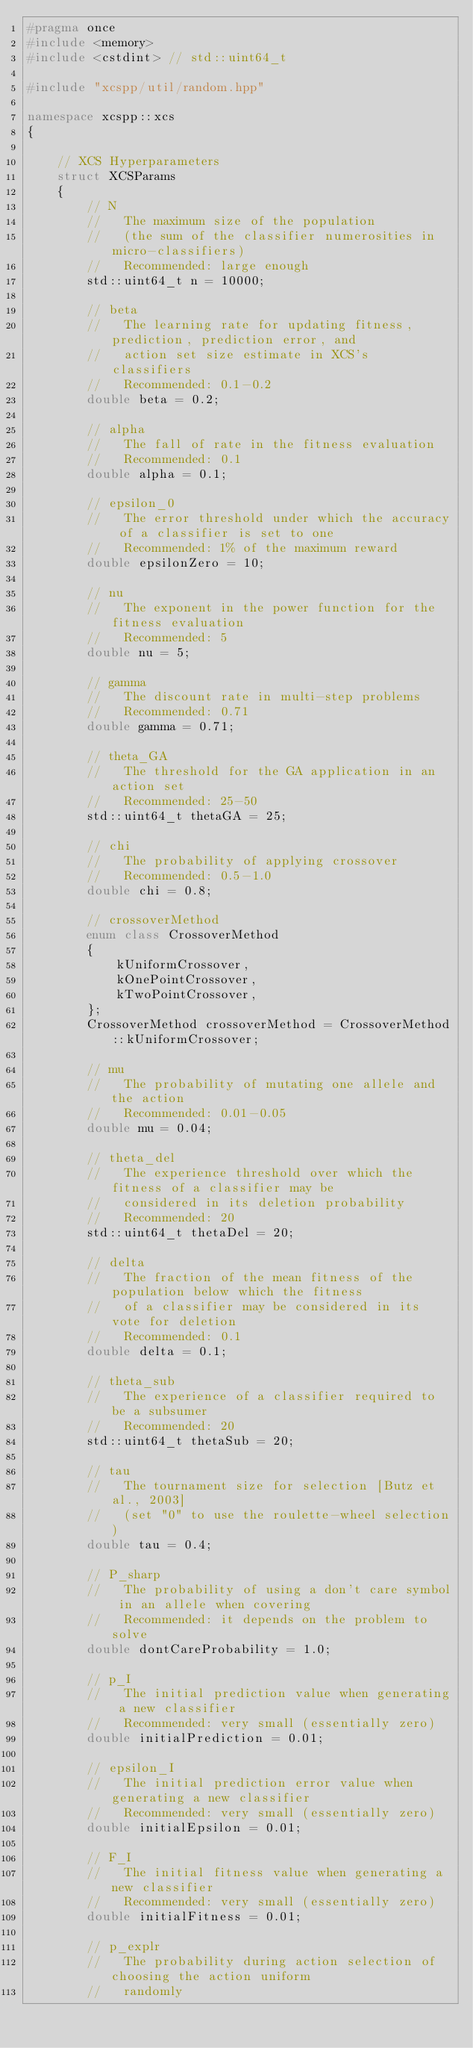<code> <loc_0><loc_0><loc_500><loc_500><_C++_>#pragma once
#include <memory>
#include <cstdint> // std::uint64_t

#include "xcspp/util/random.hpp"

namespace xcspp::xcs
{

    // XCS Hyperparameters
    struct XCSParams
    {
        // N
        //   The maximum size of the population
        //   (the sum of the classifier numerosities in micro-classifiers)
        //   Recommended: large enough
        std::uint64_t n = 10000;

        // beta
        //   The learning rate for updating fitness, prediction, prediction error, and
        //   action set size estimate in XCS's classifiers
        //   Recommended: 0.1-0.2
        double beta = 0.2;

        // alpha
        //   The fall of rate in the fitness evaluation
        //   Recommended: 0.1
        double alpha = 0.1;

        // epsilon_0
        //   The error threshold under which the accuracy of a classifier is set to one
        //   Recommended: 1% of the maximum reward
        double epsilonZero = 10;

        // nu
        //   The exponent in the power function for the fitness evaluation
        //   Recommended: 5
        double nu = 5;

        // gamma
        //   The discount rate in multi-step problems
        //   Recommended: 0.71
        double gamma = 0.71;

        // theta_GA
        //   The threshold for the GA application in an action set
        //   Recommended: 25-50
        std::uint64_t thetaGA = 25;

        // chi
        //   The probability of applying crossover
        //   Recommended: 0.5-1.0
        double chi = 0.8;

        // crossoverMethod
        enum class CrossoverMethod
        {
            kUniformCrossover,
            kOnePointCrossover,
            kTwoPointCrossover,
        };
        CrossoverMethod crossoverMethod = CrossoverMethod::kUniformCrossover;

        // mu
        //   The probability of mutating one allele and the action
        //   Recommended: 0.01-0.05
        double mu = 0.04;

        // theta_del
        //   The experience threshold over which the fitness of a classifier may be
        //   considered in its deletion probability
        //   Recommended: 20
        std::uint64_t thetaDel = 20;

        // delta
        //   The fraction of the mean fitness of the population below which the fitness
        //   of a classifier may be considered in its vote for deletion
        //   Recommended: 0.1
        double delta = 0.1;

        // theta_sub
        //   The experience of a classifier required to be a subsumer
        //   Recommended: 20
        std::uint64_t thetaSub = 20;

        // tau
        //   The tournament size for selection [Butz et al., 2003]
        //   (set "0" to use the roulette-wheel selection)
        double tau = 0.4;

        // P_sharp
        //   The probability of using a don't care symbol in an allele when covering
        //   Recommended: it depends on the problem to solve
        double dontCareProbability = 1.0;

        // p_I
        //   The initial prediction value when generating a new classifier
        //   Recommended: very small (essentially zero)
        double initialPrediction = 0.01;

        // epsilon_I
        //   The initial prediction error value when generating a new classifier
        //   Recommended: very small (essentially zero)
        double initialEpsilon = 0.01;

        // F_I
        //   The initial fitness value when generating a new classifier
        //   Recommended: very small (essentially zero)
        double initialFitness = 0.01;

        // p_explr
        //   The probability during action selection of choosing the action uniform
        //   randomly</code> 